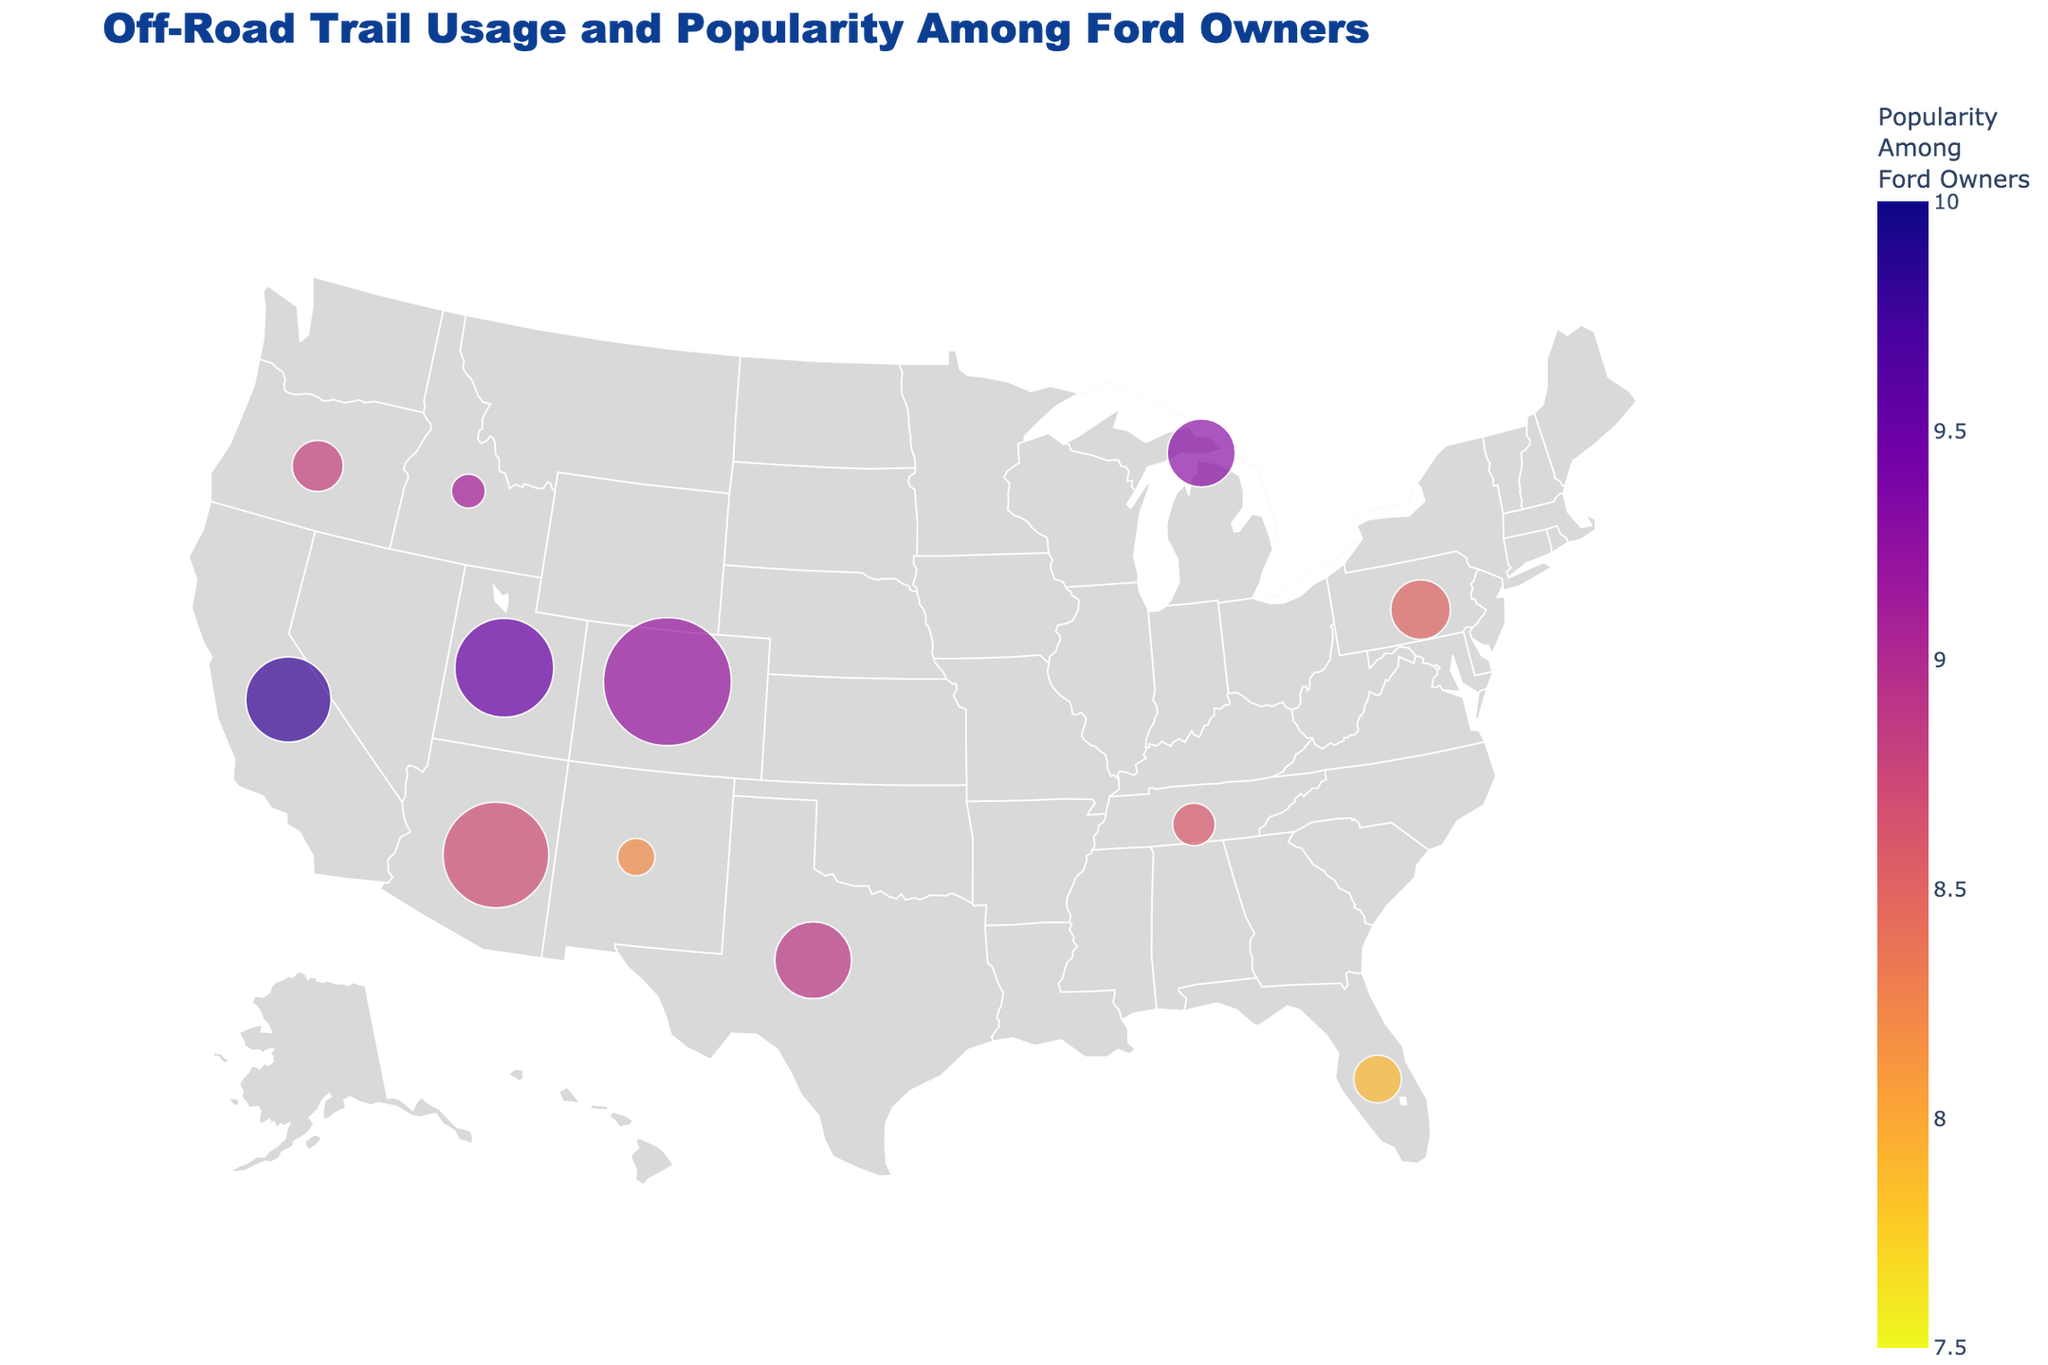What is the title of the figure? The title of the figure is prominently displayed at the top and helps the viewer understand the theme of the plot.
Answer: Off-Road Trail Usage and Popularity Among Ford Owners What colors are used to represent the popularity among Ford owners? The color scale ranges from light to dark colors to represent lower to higher popularity among Ford owners. This can be seen in the color bar on the right side of the plot.
Answer: Colors range from light to dark Which trail has the highest annual usage rate? By comparing the sizes of the markers which represent the annual usage rates, we can identify the largest marker on the map. This marker corresponds to the Moab Rim Trail in Colorado.
Answer: Moab Rim Trail What is the popularity score of the Rubicon Trail in California among Ford owners? By looking at the marker placed in California, the Rubicon Trail has a popularity score indicated in the text on hover or checking the color corresponding to the legend.
Answer: 9.8 How many trails have an annual usage rate higher than 50,000? By counting the number of markers with a size larger than those marked under 50,000 annual usage, there are four trails meeting this criterion.
Answer: Four trails Which trail in Michigan is represented, and what is its annual usage rate? The marker in Michigan specifies the trail name and its annual usage rate, which can be verified by checking the text on hover in the figure.
Answer: Drummond Island, 40,000 Among the trails plotted, which one has the lowest popularity among Ford owners and where is it located? Identify the marker with the lowest color intensity on the color scale and check its location in the figure for the relevant trail and region.
Answer: Ocala National Forest, Florida Compare the annual usage rates of the Hell's Revenge trail in Utah and the Red Rock Park trail in New Mexico. Which one is higher and by how much? By checking the sizes of the markers for Hell's Revenge and Red Rock Park, we see Hell's Revenge has 58,000 while Red Rock Park has 22,000. Subtract the smaller from the larger to find the difference.
Answer: Hell's Revenge, 36,000 higher What is the average popularity score among the listed trails for Ford owners? Sum the popularity scores of all trails and divide by the number of trails: (9.2 + 8.7 + 9.5 + 9.8 + 8.9 + 9.3 + 8.5 + 8.8 + 7.9 + 8.6 + 8.2 + 9.1) / 12 = 8.83.
Answer: 8.83 Which region shows the highest concentration of popular off-road trails for Ford owners judging by marker size and color? Considering both popularity color intensity and marker sizes in the geographical plot, the region with several highly popular trails is clearly visible.
Answer: Western United States (e.g., Utah, Colorado) 